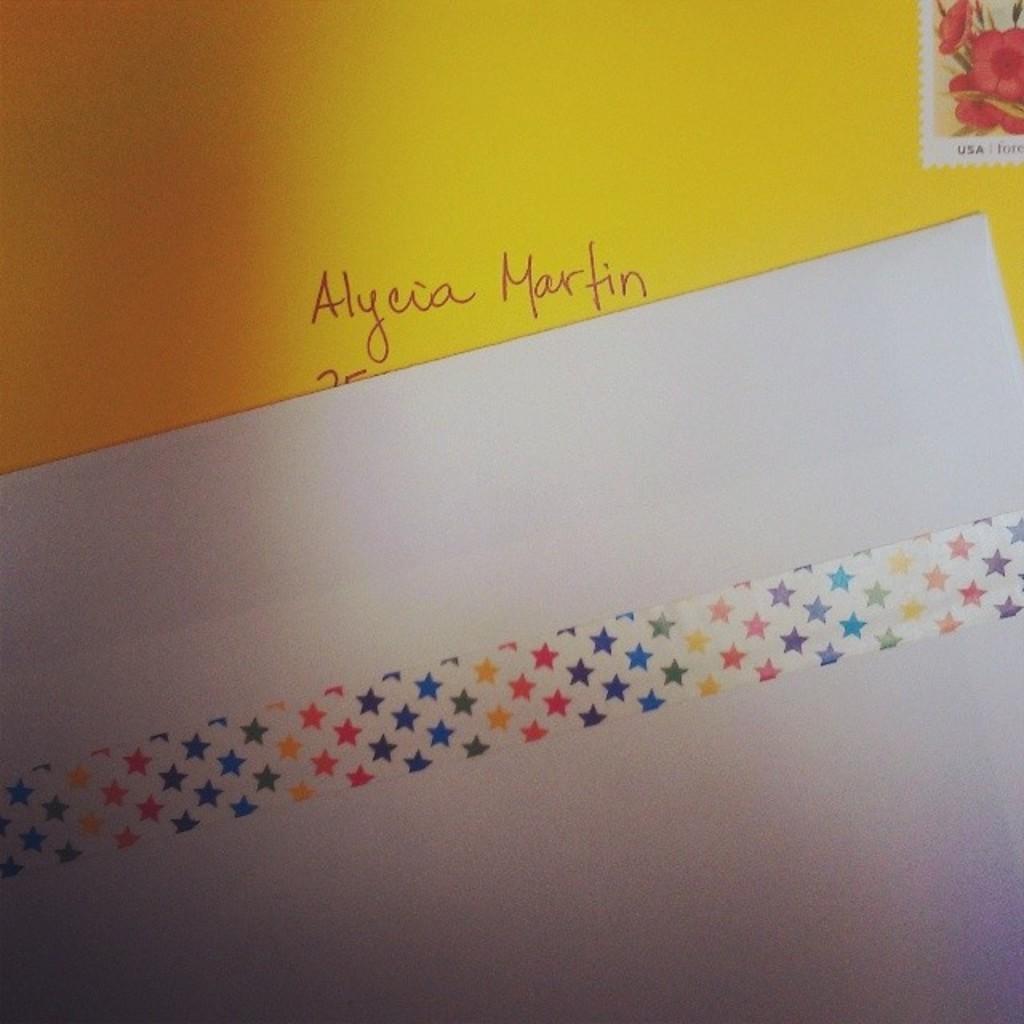What country is the stamp for?
Provide a short and direct response. Usa. What is the last name of the recipient?
Offer a very short reply. Martin. 